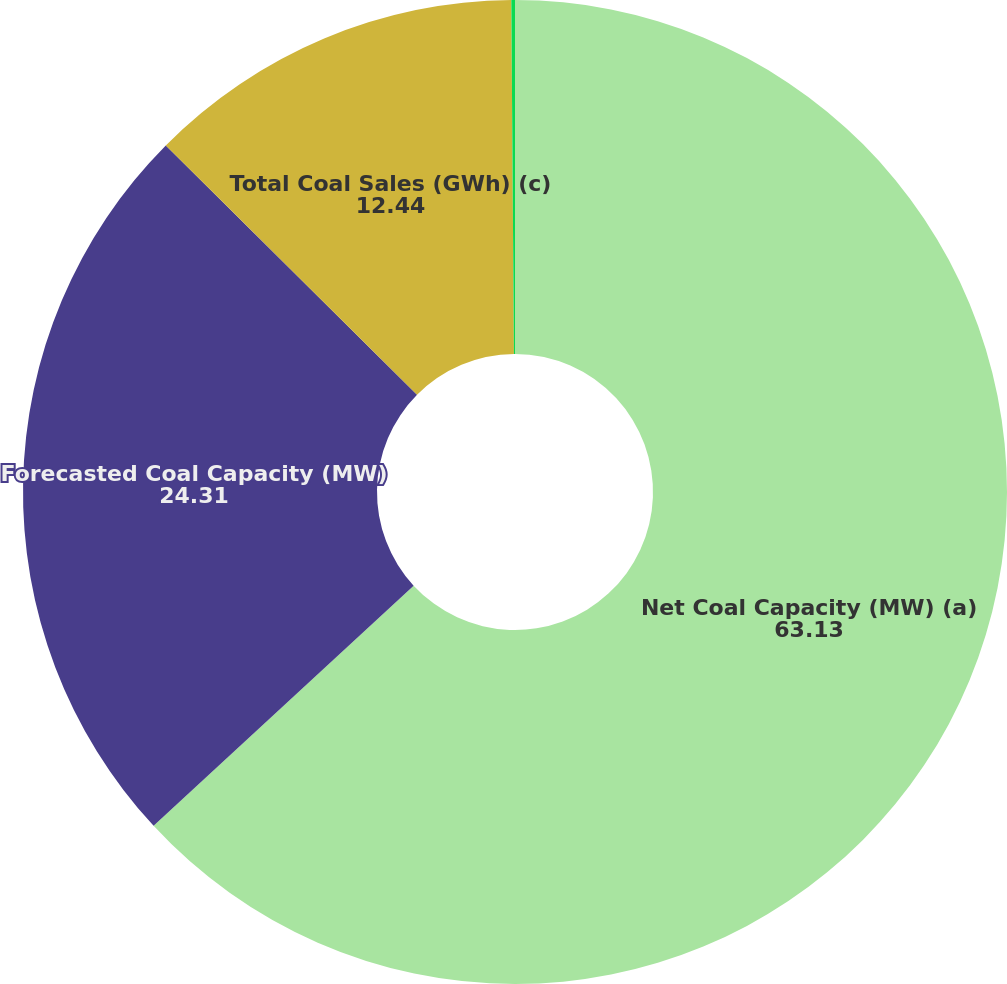Convert chart to OTSL. <chart><loc_0><loc_0><loc_500><loc_500><pie_chart><fcel>Net Coal Capacity (MW) (a)<fcel>Forecasted Coal Capacity (MW)<fcel>Total Coal Sales (GWh) (c)<fcel>Percentage Coal Capacity Sold<nl><fcel>63.13%<fcel>24.31%<fcel>12.44%<fcel>0.12%<nl></chart> 